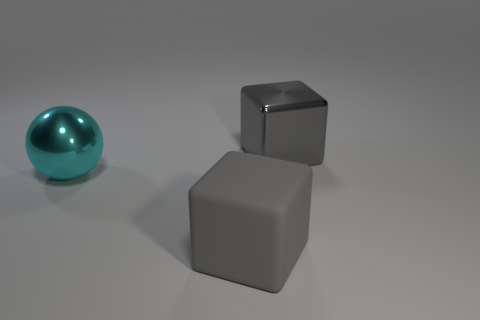What number of other objects are there of the same shape as the big cyan object?
Provide a succinct answer. 0. How many things are blocks that are behind the gray matte thing or gray objects that are behind the big gray rubber cube?
Give a very brief answer. 1. Does the big gray metallic object have the same shape as the big object in front of the big cyan shiny thing?
Your answer should be compact. Yes. What shape is the object that is behind the large shiny thing that is on the left side of the gray block to the right of the gray matte object?
Your answer should be very brief. Cube. How many other objects are the same material as the cyan thing?
Provide a short and direct response. 1. How many things are either gray cubes in front of the big metal sphere or large green metal balls?
Offer a very short reply. 1. What is the shape of the large gray thing left of the big object that is behind the cyan sphere?
Ensure brevity in your answer.  Cube. Does the large metal thing that is right of the matte thing have the same shape as the big matte thing?
Provide a succinct answer. Yes. There is a thing that is in front of the cyan object; what is its color?
Provide a short and direct response. Gray. How many cylinders are big cyan things or big matte objects?
Give a very brief answer. 0. 